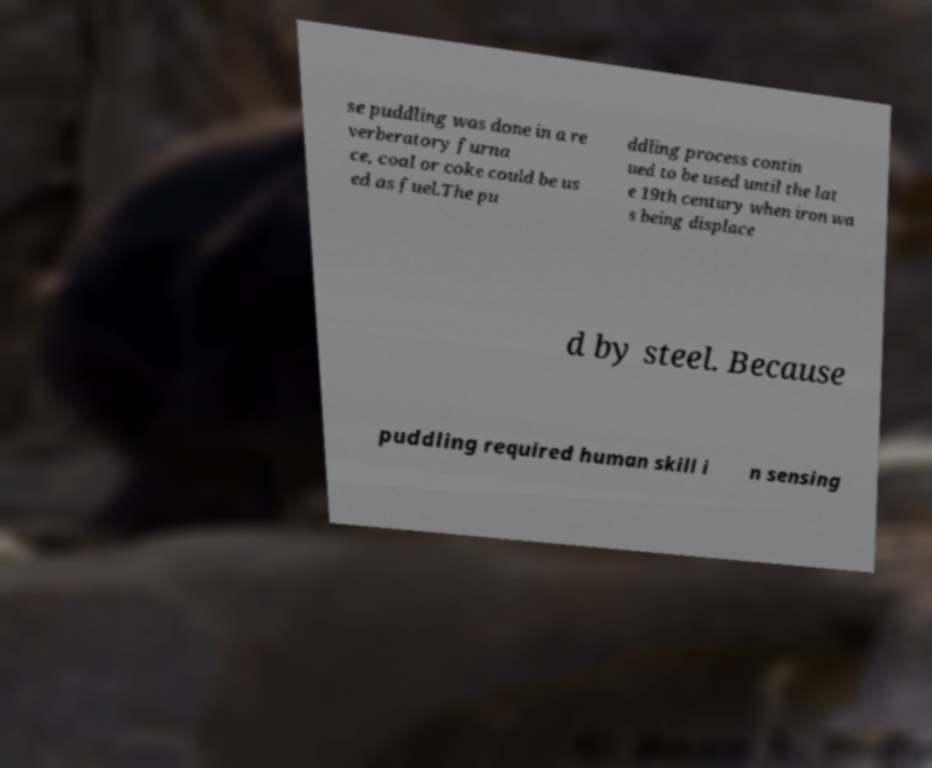For documentation purposes, I need the text within this image transcribed. Could you provide that? se puddling was done in a re verberatory furna ce, coal or coke could be us ed as fuel.The pu ddling process contin ued to be used until the lat e 19th century when iron wa s being displace d by steel. Because puddling required human skill i n sensing 